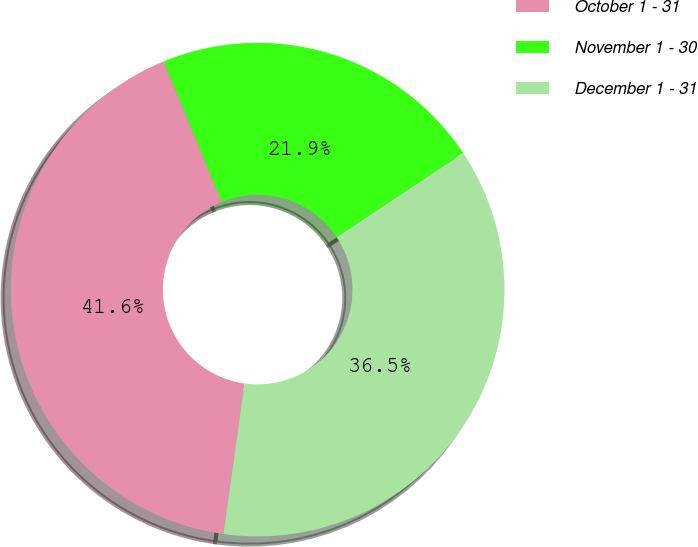Convert chart to OTSL. <chart><loc_0><loc_0><loc_500><loc_500><pie_chart><fcel>October 1 - 31<fcel>November 1 - 30<fcel>December 1 - 31<nl><fcel>41.57%<fcel>21.88%<fcel>36.55%<nl></chart> 